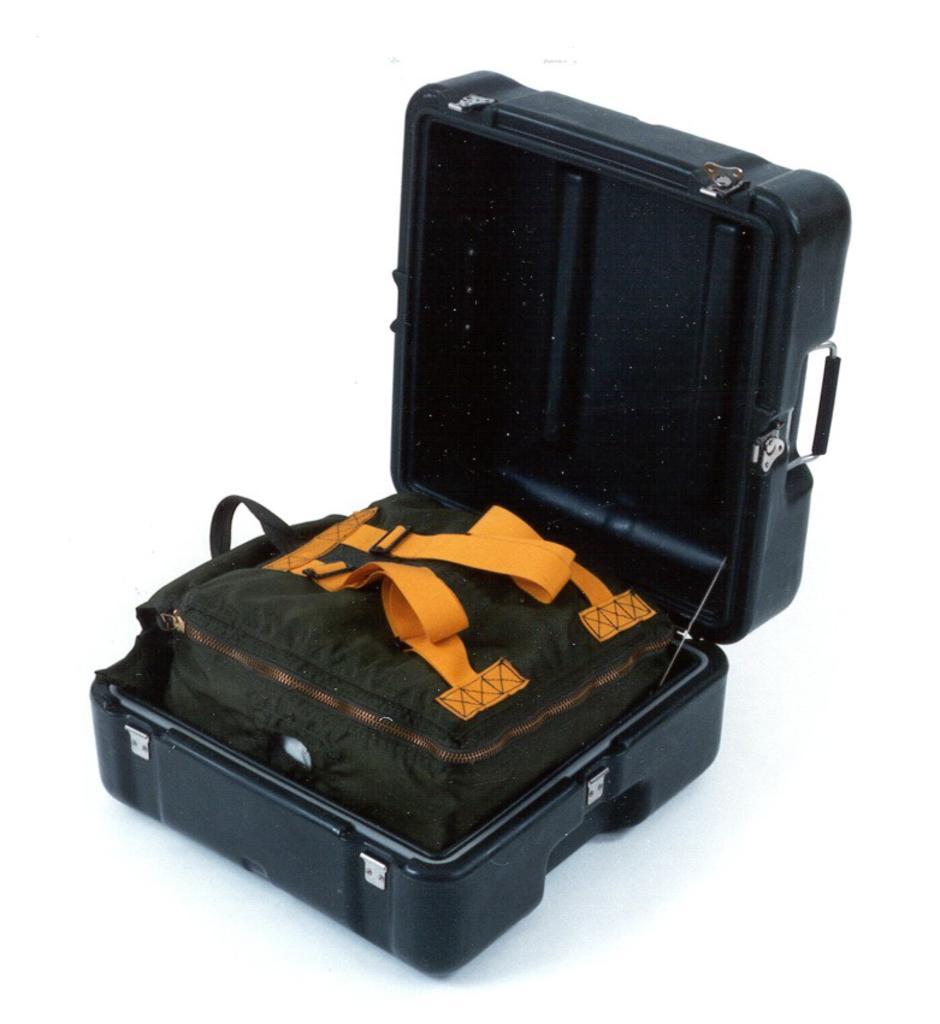Please provide a concise description of this image. There is a black container which has green bag with yellow handles to it. 